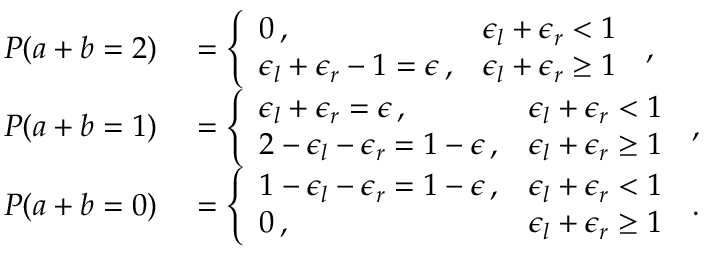Convert formula to latex. <formula><loc_0><loc_0><loc_500><loc_500>\begin{array} { r l } { P ( a + b = 2 ) } & = \left \{ \begin{array} { l l } { 0 \, , } & { \epsilon _ { l } + \epsilon _ { r } < 1 } \\ { \epsilon _ { l } + \epsilon _ { r } - 1 = \epsilon \, , } & { \epsilon _ { l } + \epsilon _ { r } \geq 1 } \end{array} \, , } \\ { P ( a + b = 1 ) } & = \left \{ \begin{array} { l l } { \epsilon _ { l } + \epsilon _ { r } = \epsilon \, , } & { \epsilon _ { l } + \epsilon _ { r } < 1 } \\ { 2 - \epsilon _ { l } - \epsilon _ { r } = 1 - \epsilon \, , } & { \epsilon _ { l } + \epsilon _ { r } \geq 1 } \end{array} \, , } \\ { P ( a + b = 0 ) } & = \left \{ \begin{array} { l l } { 1 - \epsilon _ { l } - \epsilon _ { r } = 1 - \epsilon \, , } & { \epsilon _ { l } + \epsilon _ { r } < 1 } \\ { 0 \, , } & { \epsilon _ { l } + \epsilon _ { r } \geq 1 } \end{array} \, . } \end{array}</formula> 